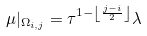<formula> <loc_0><loc_0><loc_500><loc_500>\mu | _ { \Omega _ { i , j } } = \tau ^ { 1 - \left \lfloor \frac { j - i } { 2 } \right \rfloor } \lambda</formula> 